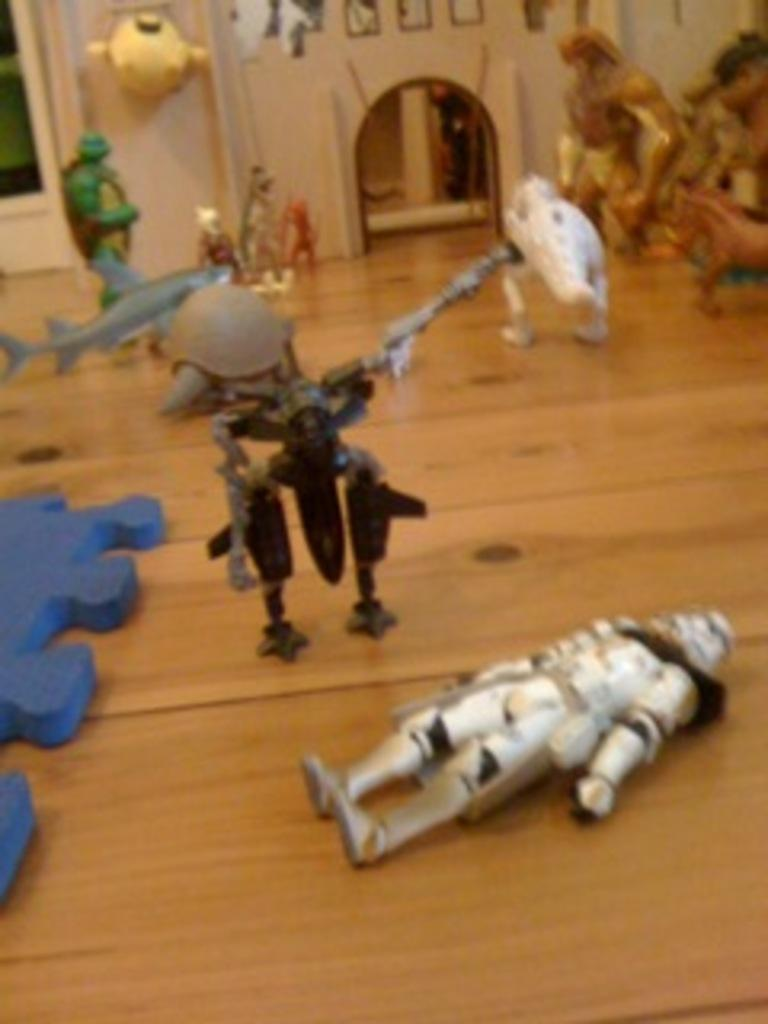What is on the floor in the image? There are toys on the floor in the image. What else can be seen in the image besides the toys? There are objects visible in the image. What can be seen in the background of the image? There is a wall, a door, and photo frames in the background of the image. Can you describe the setting where the image might have been taken? The image may have been taken in a hall. What type of crime is being committed in the image? There is no crime being committed in the image; it features toys on the floor and objects in a hall. How many birds are visible in the image? There are no birds present in the image. 